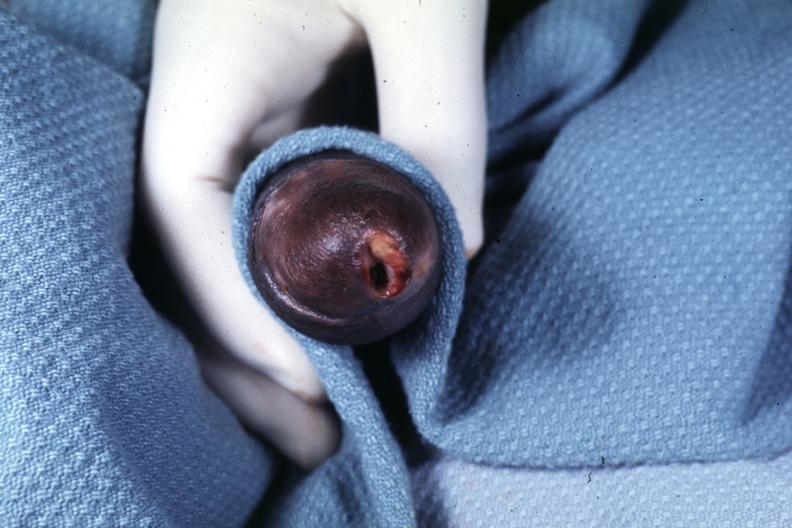what does this image show?
Answer the question using a single word or phrase. Glans ulcer probable herpes 